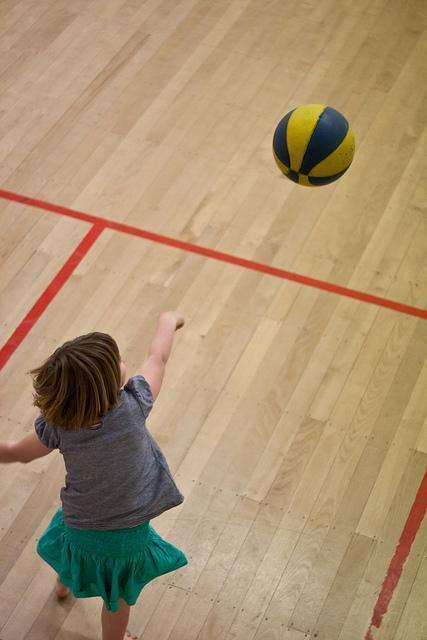How many children in the picture?
Give a very brief answer. 1. How many people are visible?
Give a very brief answer. 1. How many orange pieces can you see?
Give a very brief answer. 0. 